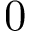Convert formula to latex. <formula><loc_0><loc_0><loc_500><loc_500>0</formula> 